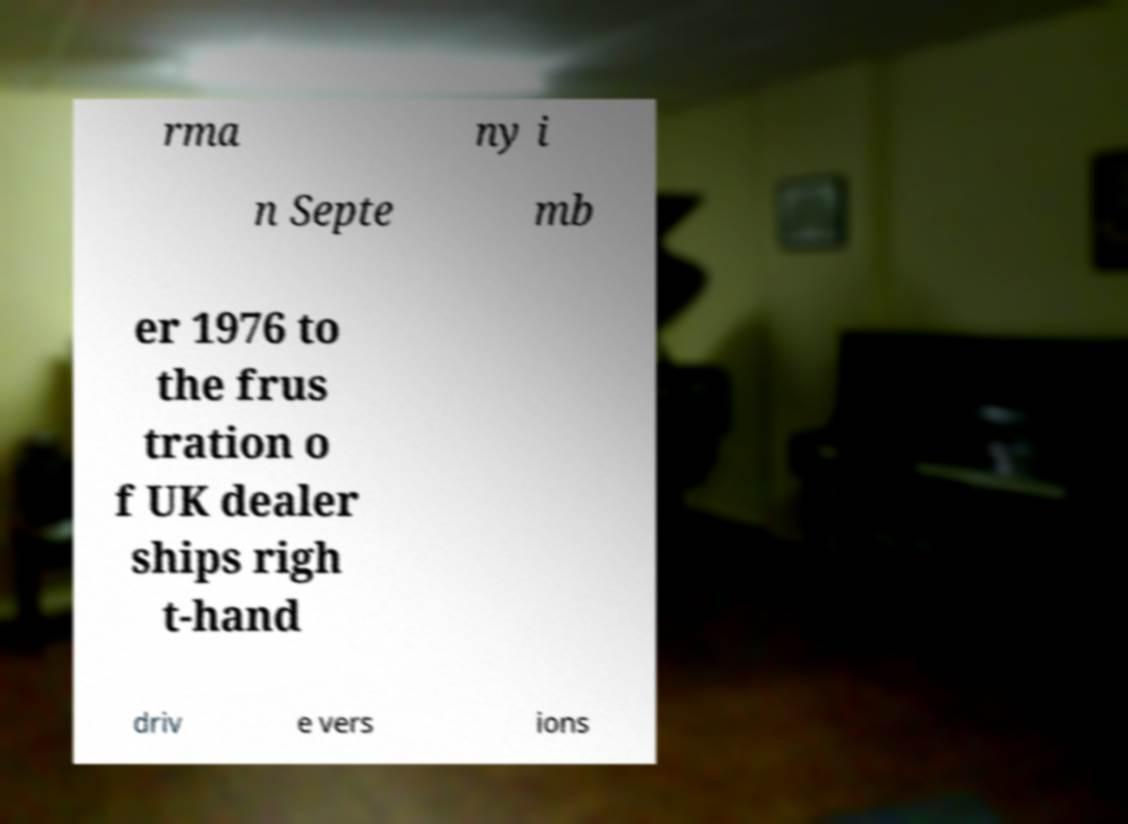Can you read and provide the text displayed in the image?This photo seems to have some interesting text. Can you extract and type it out for me? rma ny i n Septe mb er 1976 to the frus tration o f UK dealer ships righ t-hand driv e vers ions 